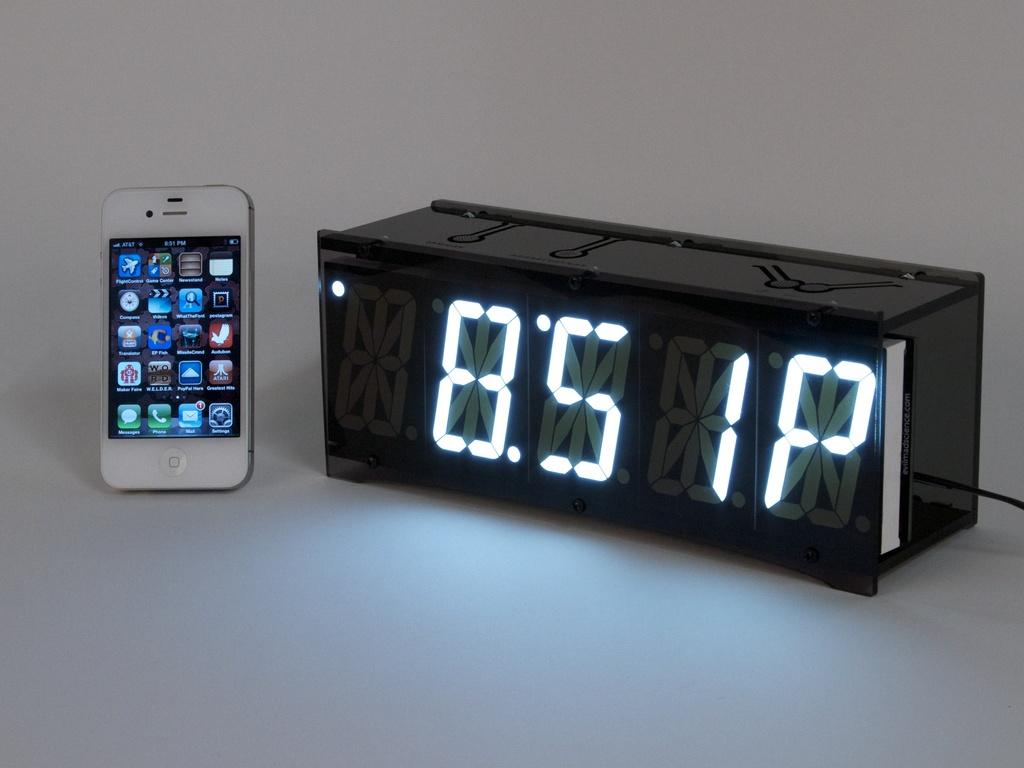What does the clock read?
Your response must be concise. 8:51p. What is the icon in the lower left of th ephone?
Offer a very short reply. Messages. 